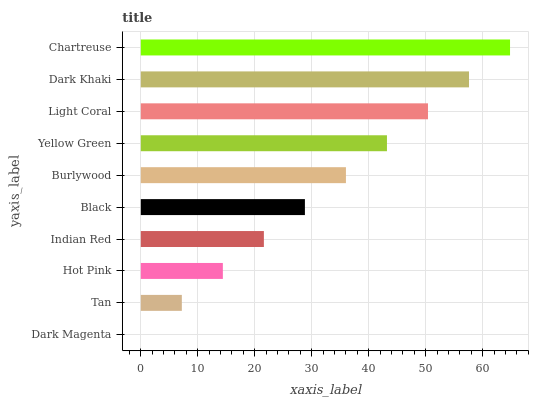Is Dark Magenta the minimum?
Answer yes or no. Yes. Is Chartreuse the maximum?
Answer yes or no. Yes. Is Tan the minimum?
Answer yes or no. No. Is Tan the maximum?
Answer yes or no. No. Is Tan greater than Dark Magenta?
Answer yes or no. Yes. Is Dark Magenta less than Tan?
Answer yes or no. Yes. Is Dark Magenta greater than Tan?
Answer yes or no. No. Is Tan less than Dark Magenta?
Answer yes or no. No. Is Burlywood the high median?
Answer yes or no. Yes. Is Black the low median?
Answer yes or no. Yes. Is Tan the high median?
Answer yes or no. No. Is Burlywood the low median?
Answer yes or no. No. 